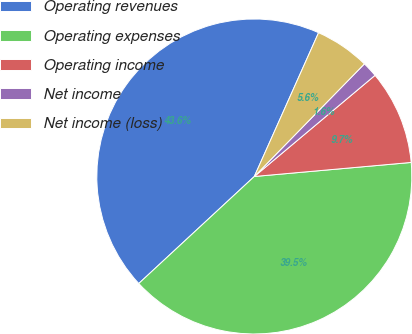<chart> <loc_0><loc_0><loc_500><loc_500><pie_chart><fcel>Operating revenues<fcel>Operating expenses<fcel>Operating income<fcel>Net income<fcel>Net income (loss)<nl><fcel>43.58%<fcel>39.53%<fcel>9.68%<fcel>1.58%<fcel>5.63%<nl></chart> 